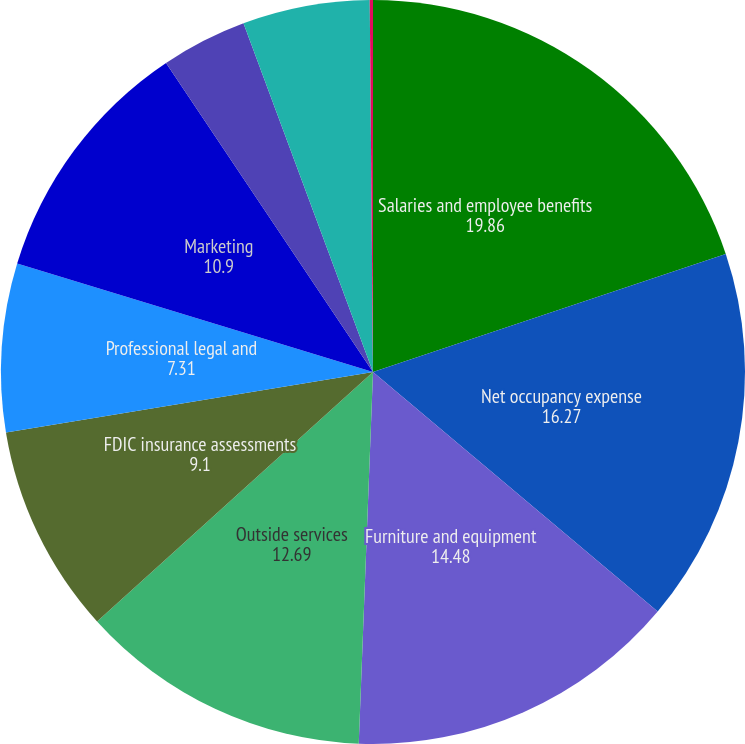<chart> <loc_0><loc_0><loc_500><loc_500><pie_chart><fcel>Salaries and employee benefits<fcel>Net occupancy expense<fcel>Furniture and equipment<fcel>Outside services<fcel>FDIC insurance assessments<fcel>Professional legal and<fcel>Marketing<fcel>Credit/checkcard expenses<fcel>Branch consolidation property<fcel>Visa class B shares expense<nl><fcel>19.86%<fcel>16.27%<fcel>14.48%<fcel>12.69%<fcel>9.1%<fcel>7.31%<fcel>10.9%<fcel>3.73%<fcel>5.52%<fcel>0.14%<nl></chart> 